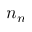<formula> <loc_0><loc_0><loc_500><loc_500>n _ { n }</formula> 